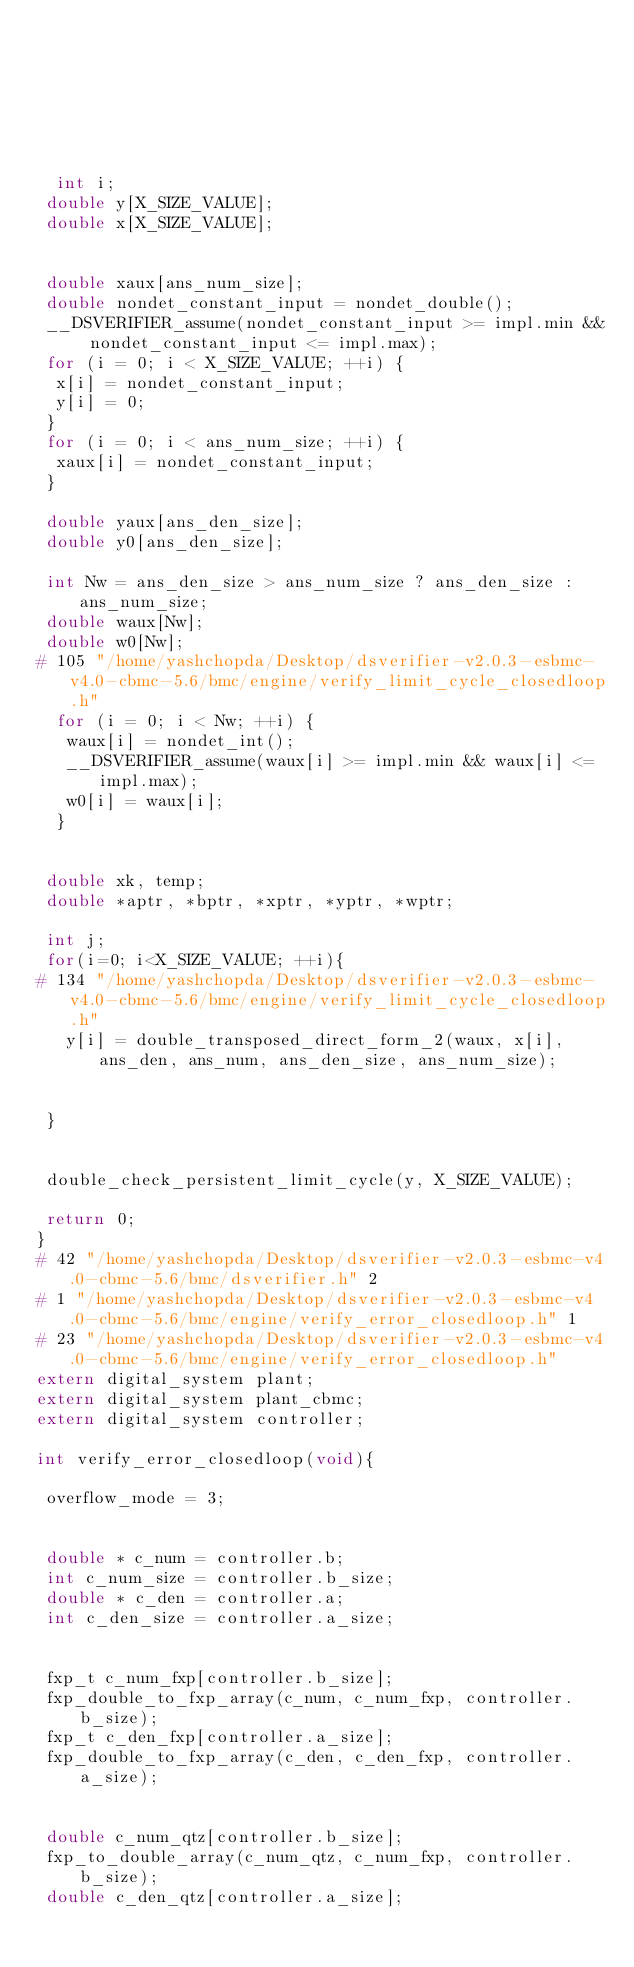Convert code to text. <code><loc_0><loc_0><loc_500><loc_500><_C_>






  int i;
 double y[X_SIZE_VALUE];
 double x[X_SIZE_VALUE];


 double xaux[ans_num_size];
 double nondet_constant_input = nondet_double();
 __DSVERIFIER_assume(nondet_constant_input >= impl.min && nondet_constant_input <= impl.max);
 for (i = 0; i < X_SIZE_VALUE; ++i) {
  x[i] = nondet_constant_input;
  y[i] = 0;
 }
 for (i = 0; i < ans_num_size; ++i) {
  xaux[i] = nondet_constant_input;
 }

 double yaux[ans_den_size];
 double y0[ans_den_size];

 int Nw = ans_den_size > ans_num_size ? ans_den_size : ans_num_size;
 double waux[Nw];
 double w0[Nw];
# 105 "/home/yashchopda/Desktop/dsverifier-v2.0.3-esbmc-v4.0-cbmc-5.6/bmc/engine/verify_limit_cycle_closedloop.h"
  for (i = 0; i < Nw; ++i) {
   waux[i] = nondet_int();
   __DSVERIFIER_assume(waux[i] >= impl.min && waux[i] <= impl.max);
   w0[i] = waux[i];
  }


 double xk, temp;
 double *aptr, *bptr, *xptr, *yptr, *wptr;

 int j;
 for(i=0; i<X_SIZE_VALUE; ++i){
# 134 "/home/yashchopda/Desktop/dsverifier-v2.0.3-esbmc-v4.0-cbmc-5.6/bmc/engine/verify_limit_cycle_closedloop.h"
   y[i] = double_transposed_direct_form_2(waux, x[i], ans_den, ans_num, ans_den_size, ans_num_size);


 }


 double_check_persistent_limit_cycle(y, X_SIZE_VALUE);

 return 0;
}
# 42 "/home/yashchopda/Desktop/dsverifier-v2.0.3-esbmc-v4.0-cbmc-5.6/bmc/dsverifier.h" 2
# 1 "/home/yashchopda/Desktop/dsverifier-v2.0.3-esbmc-v4.0-cbmc-5.6/bmc/engine/verify_error_closedloop.h" 1
# 23 "/home/yashchopda/Desktop/dsverifier-v2.0.3-esbmc-v4.0-cbmc-5.6/bmc/engine/verify_error_closedloop.h"
extern digital_system plant;
extern digital_system plant_cbmc;
extern digital_system controller;

int verify_error_closedloop(void){

 overflow_mode = 3;


 double * c_num = controller.b;
 int c_num_size = controller.b_size;
 double * c_den = controller.a;
 int c_den_size = controller.a_size;


 fxp_t c_num_fxp[controller.b_size];
 fxp_double_to_fxp_array(c_num, c_num_fxp, controller.b_size);
 fxp_t c_den_fxp[controller.a_size];
 fxp_double_to_fxp_array(c_den, c_den_fxp, controller.a_size);


 double c_num_qtz[controller.b_size];
 fxp_to_double_array(c_num_qtz, c_num_fxp, controller.b_size);
 double c_den_qtz[controller.a_size];</code> 